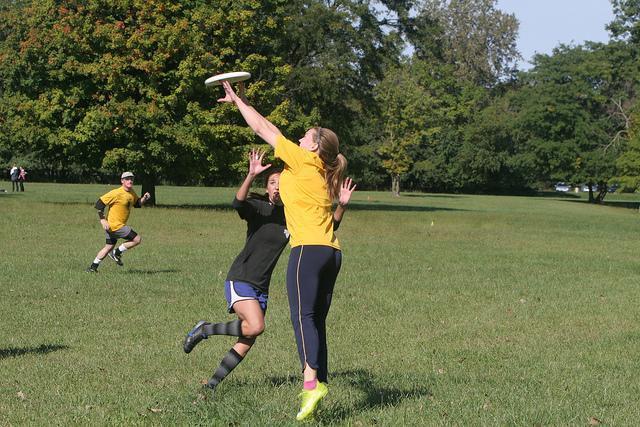How many players are on the field?
Give a very brief answer. 3. How many people are there?
Give a very brief answer. 3. 